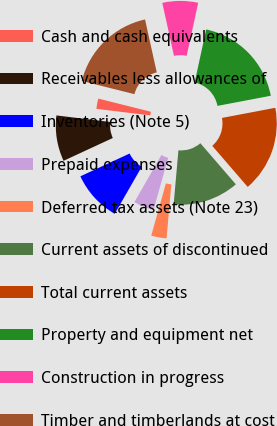Convert chart to OTSL. <chart><loc_0><loc_0><loc_500><loc_500><pie_chart><fcel>Cash and cash equivalents<fcel>Receivables less allowances of<fcel>Inventories (Note 5)<fcel>Prepaid expenses<fcel>Deferred tax assets (Note 23)<fcel>Current assets of discontinued<fcel>Total current assets<fcel>Property and equipment net<fcel>Construction in progress<fcel>Timber and timberlands at cost<nl><fcel>1.98%<fcel>8.83%<fcel>9.8%<fcel>3.94%<fcel>2.96%<fcel>12.74%<fcel>16.65%<fcel>18.61%<fcel>6.87%<fcel>17.63%<nl></chart> 